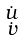<formula> <loc_0><loc_0><loc_500><loc_500>\begin{smallmatrix} \dot { u } \\ \dot { v } \\ \end{smallmatrix}</formula> 